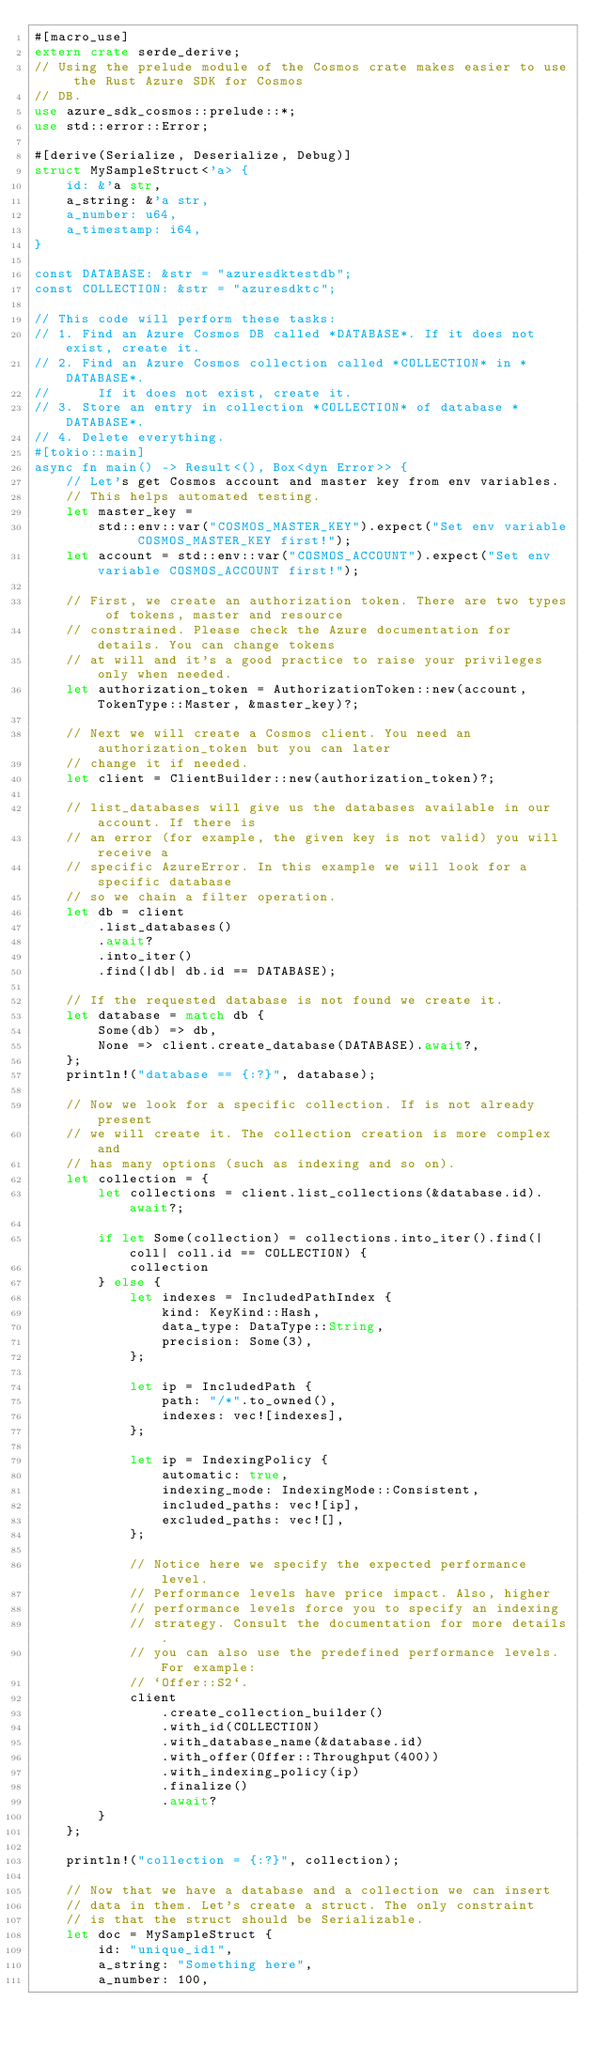Convert code to text. <code><loc_0><loc_0><loc_500><loc_500><_Rust_>#[macro_use]
extern crate serde_derive;
// Using the prelude module of the Cosmos crate makes easier to use the Rust Azure SDK for Cosmos
// DB.
use azure_sdk_cosmos::prelude::*;
use std::error::Error;

#[derive(Serialize, Deserialize, Debug)]
struct MySampleStruct<'a> {
    id: &'a str,
    a_string: &'a str,
    a_number: u64,
    a_timestamp: i64,
}

const DATABASE: &str = "azuresdktestdb";
const COLLECTION: &str = "azuresdktc";

// This code will perform these tasks:
// 1. Find an Azure Cosmos DB called *DATABASE*. If it does not exist, create it.
// 2. Find an Azure Cosmos collection called *COLLECTION* in *DATABASE*.
//      If it does not exist, create it.
// 3. Store an entry in collection *COLLECTION* of database *DATABASE*.
// 4. Delete everything.
#[tokio::main]
async fn main() -> Result<(), Box<dyn Error>> {
    // Let's get Cosmos account and master key from env variables.
    // This helps automated testing.
    let master_key =
        std::env::var("COSMOS_MASTER_KEY").expect("Set env variable COSMOS_MASTER_KEY first!");
    let account = std::env::var("COSMOS_ACCOUNT").expect("Set env variable COSMOS_ACCOUNT first!");

    // First, we create an authorization token. There are two types of tokens, master and resource
    // constrained. Please check the Azure documentation for details. You can change tokens
    // at will and it's a good practice to raise your privileges only when needed.
    let authorization_token = AuthorizationToken::new(account, TokenType::Master, &master_key)?;

    // Next we will create a Cosmos client. You need an authorization_token but you can later
    // change it if needed.
    let client = ClientBuilder::new(authorization_token)?;

    // list_databases will give us the databases available in our account. If there is
    // an error (for example, the given key is not valid) you will receive a
    // specific AzureError. In this example we will look for a specific database
    // so we chain a filter operation.
    let db = client
        .list_databases()
        .await?
        .into_iter()
        .find(|db| db.id == DATABASE);

    // If the requested database is not found we create it.
    let database = match db {
        Some(db) => db,
        None => client.create_database(DATABASE).await?,
    };
    println!("database == {:?}", database);

    // Now we look for a specific collection. If is not already present
    // we will create it. The collection creation is more complex and
    // has many options (such as indexing and so on).
    let collection = {
        let collections = client.list_collections(&database.id).await?;

        if let Some(collection) = collections.into_iter().find(|coll| coll.id == COLLECTION) {
            collection
        } else {
            let indexes = IncludedPathIndex {
                kind: KeyKind::Hash,
                data_type: DataType::String,
                precision: Some(3),
            };

            let ip = IncludedPath {
                path: "/*".to_owned(),
                indexes: vec![indexes],
            };

            let ip = IndexingPolicy {
                automatic: true,
                indexing_mode: IndexingMode::Consistent,
                included_paths: vec![ip],
                excluded_paths: vec![],
            };

            // Notice here we specify the expected performance level.
            // Performance levels have price impact. Also, higher
            // performance levels force you to specify an indexing
            // strategy. Consult the documentation for more details.
            // you can also use the predefined performance levels. For example:
            // `Offer::S2`.
            client
                .create_collection_builder()
                .with_id(COLLECTION)
                .with_database_name(&database.id)
                .with_offer(Offer::Throughput(400))
                .with_indexing_policy(ip)
                .finalize()
                .await?
        }
    };

    println!("collection = {:?}", collection);

    // Now that we have a database and a collection we can insert
    // data in them. Let's create a struct. The only constraint
    // is that the struct should be Serializable.
    let doc = MySampleStruct {
        id: "unique_id1",
        a_string: "Something here",
        a_number: 100,</code> 